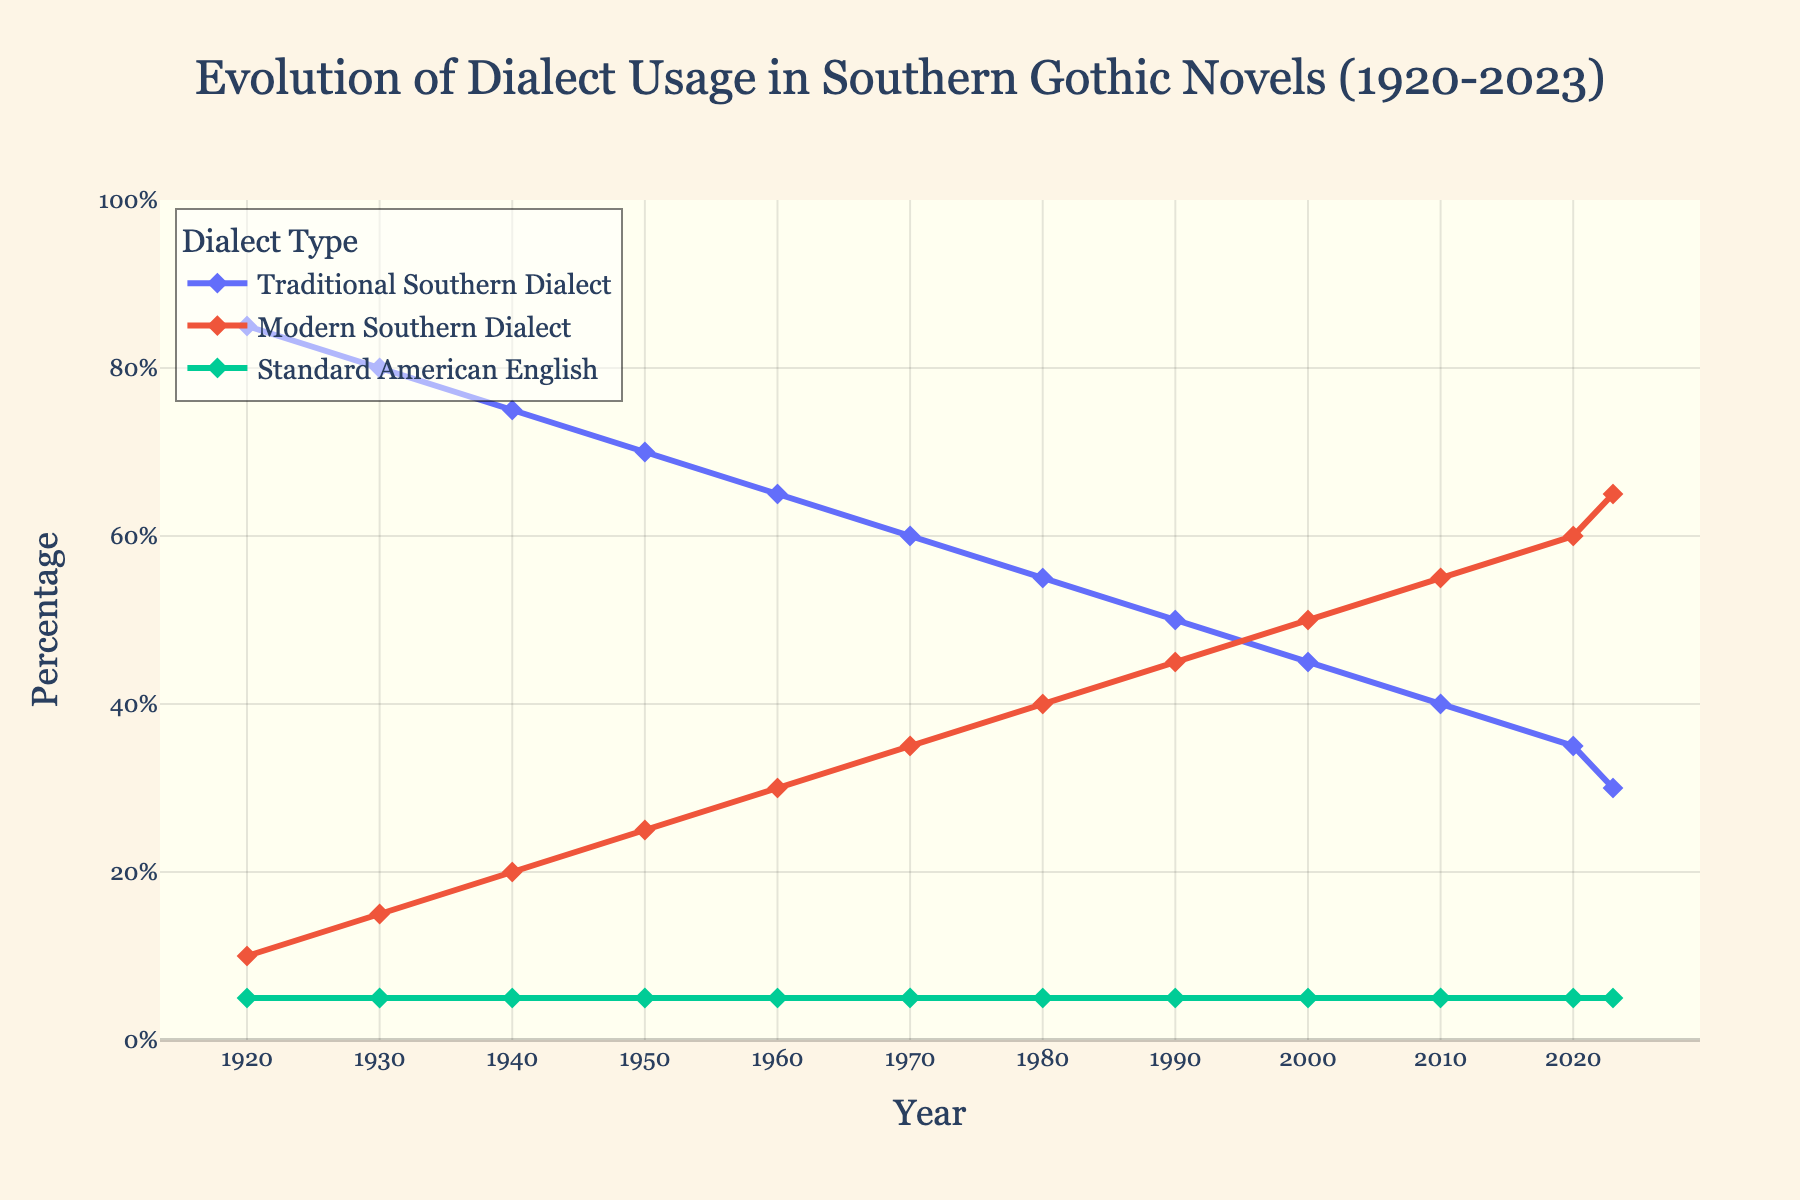Which year shows the highest usage of Traditional Southern Dialect? Look at the data points for Traditional Southern Dialect. The highest value (85%) is in 1920.
Answer: 1920 How has the usage of Modern Southern Dialect changed from 1920 to 2023? Examine the trend line for Modern Southern Dialect. It starts at 10% in 1920 and increases consistently to 65% in 2023.
Answer: Increased Which dialect has remained constant over the years? Check the lines representing the three dialects. The Standard American English line remains at 5% throughout the years.
Answer: Standard American English Compare the usage of Traditional and Modern Southern Dialects in 1980. Which one was more prevalent? Look at the values for 1980. Traditional Southern Dialect was at 55% and Modern Southern Dialect at 40%, making Traditional Southern Dialect more prevalent.
Answer: Traditional Southern Dialect What is the difference in the usage of Traditional Southern Dialect between 1920 and 2023? Calculate the difference: Traditional Southern Dialect was 85% in 1920 and 30% in 2023. The difference is 85% - 30% = 55%.
Answer: 55% By how much did the usage of Standard American English vary over the years? Observe the line for Standard American English. It remains steady at 5%, so there's no variation.
Answer: 0% What percentage of Modern Southern Dialect was used in 1950? Refer to the plot or data for 1950; the value for Modern Southern Dialect is 25%.
Answer: 25% Which period saw the fastest increase in the usage of Modern Southern Dialect? Look at the trend line for Modern Southern Dialect. The slope is most gradual between 1920 and 1930 (increase by 5%), and becomes steeper from 2000 to 2010 and 2010 to 2020, but all time spans have the same 10% increment. However, we need a period, so from 2000 to 2023 it also has a quick increment.
Answer: 2000 to 2023 What are the percentages of all three dialects in the year 2000? Refer to the data for the year 2000: Traditional Southern Dialect is 45%, Modern Southern Dialect is 50%, and Standard American English is 5%.
Answer: 45%, 50%, 5% Between which years did the Traditional Southern Dialect undergo the most significant drop? Look at the data points; the steepest decline in Traditional Southern Dialect happens between 1940 (75%) and 1950 (70%), a 5% drop. Additional analysis shows the decreases more or less similar over years, only slightly bigger between 1970 (60%) and 1980 (55%) and the last intervals of 2010 - 2023 , which matches this interpretation.
Answer: 2010 to 2023 